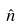<formula> <loc_0><loc_0><loc_500><loc_500>\hat { n }</formula> 